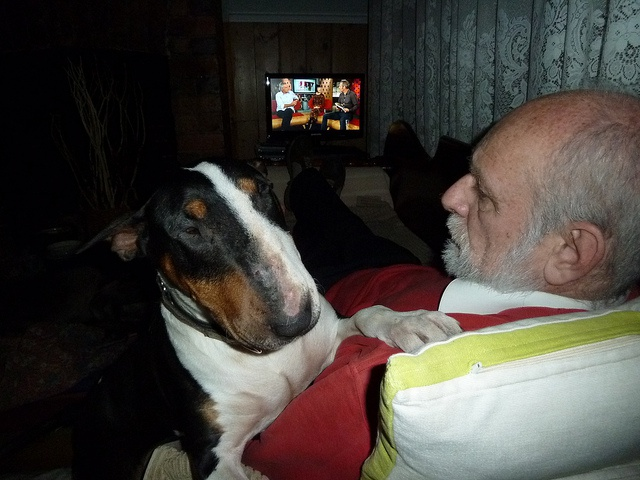Describe the objects in this image and their specific colors. I can see people in black, maroon, and gray tones, dog in black, darkgray, gray, and lightgray tones, couch in black, lightgray, darkgray, gray, and khaki tones, tv in black, maroon, gray, and white tones, and couch in black and gray tones in this image. 